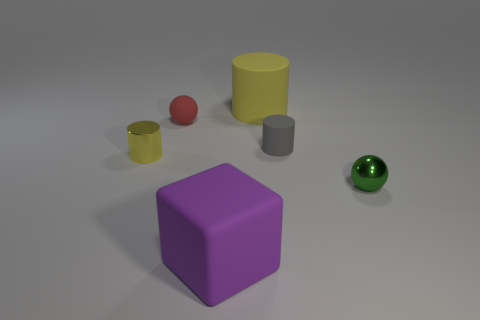Subtract all brown blocks. Subtract all gray balls. How many blocks are left? 1 Add 4 small gray objects. How many objects exist? 10 Subtract all spheres. How many objects are left? 4 Subtract all big cyan matte balls. Subtract all purple rubber objects. How many objects are left? 5 Add 2 big purple objects. How many big purple objects are left? 3 Add 5 tiny purple matte cylinders. How many tiny purple matte cylinders exist? 5 Subtract 0 blue cubes. How many objects are left? 6 